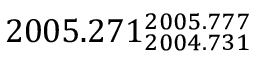Convert formula to latex. <formula><loc_0><loc_0><loc_500><loc_500>2 0 0 5 . 2 7 1 _ { 2 0 0 4 . 7 3 1 } ^ { 2 0 0 5 . 7 7 7 }</formula> 